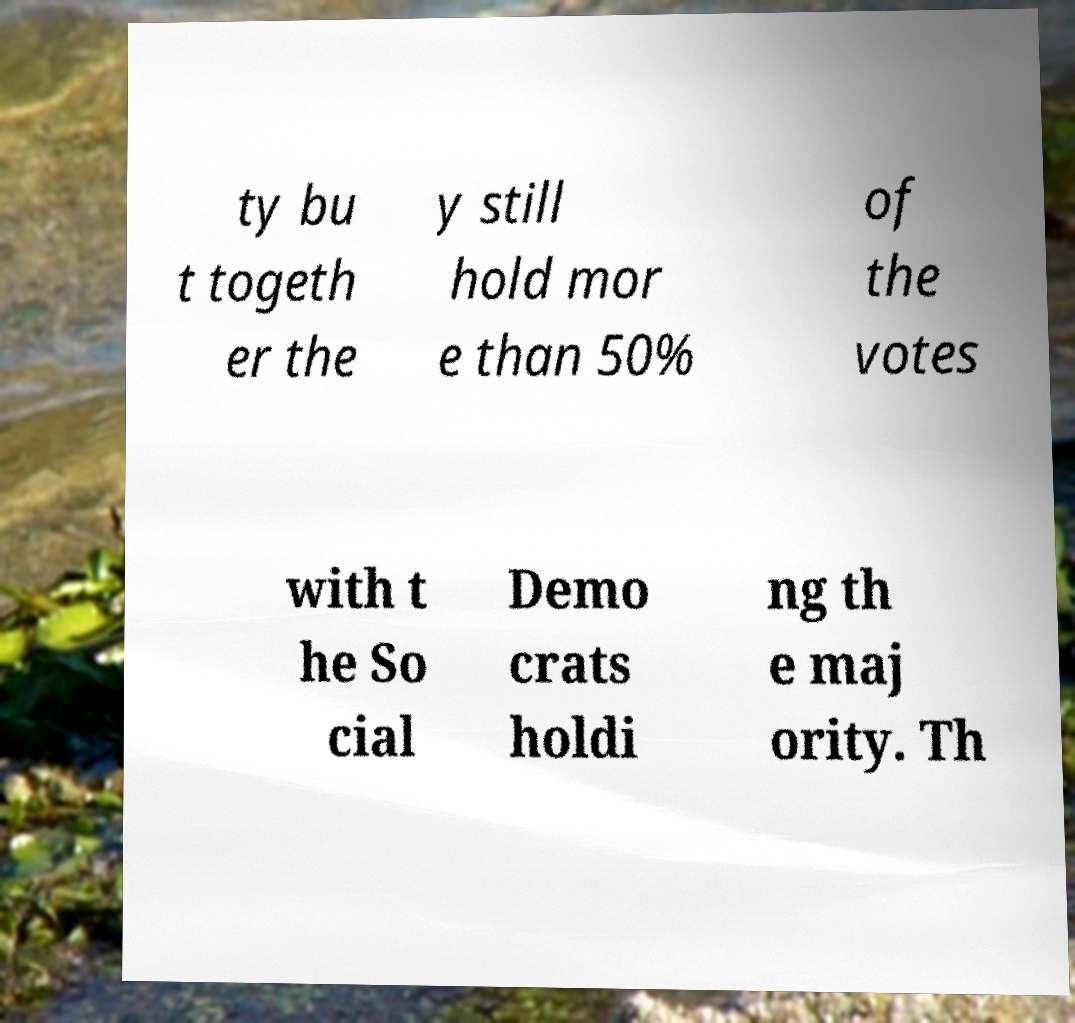What messages or text are displayed in this image? I need them in a readable, typed format. ty bu t togeth er the y still hold mor e than 50% of the votes with t he So cial Demo crats holdi ng th e maj ority. Th 